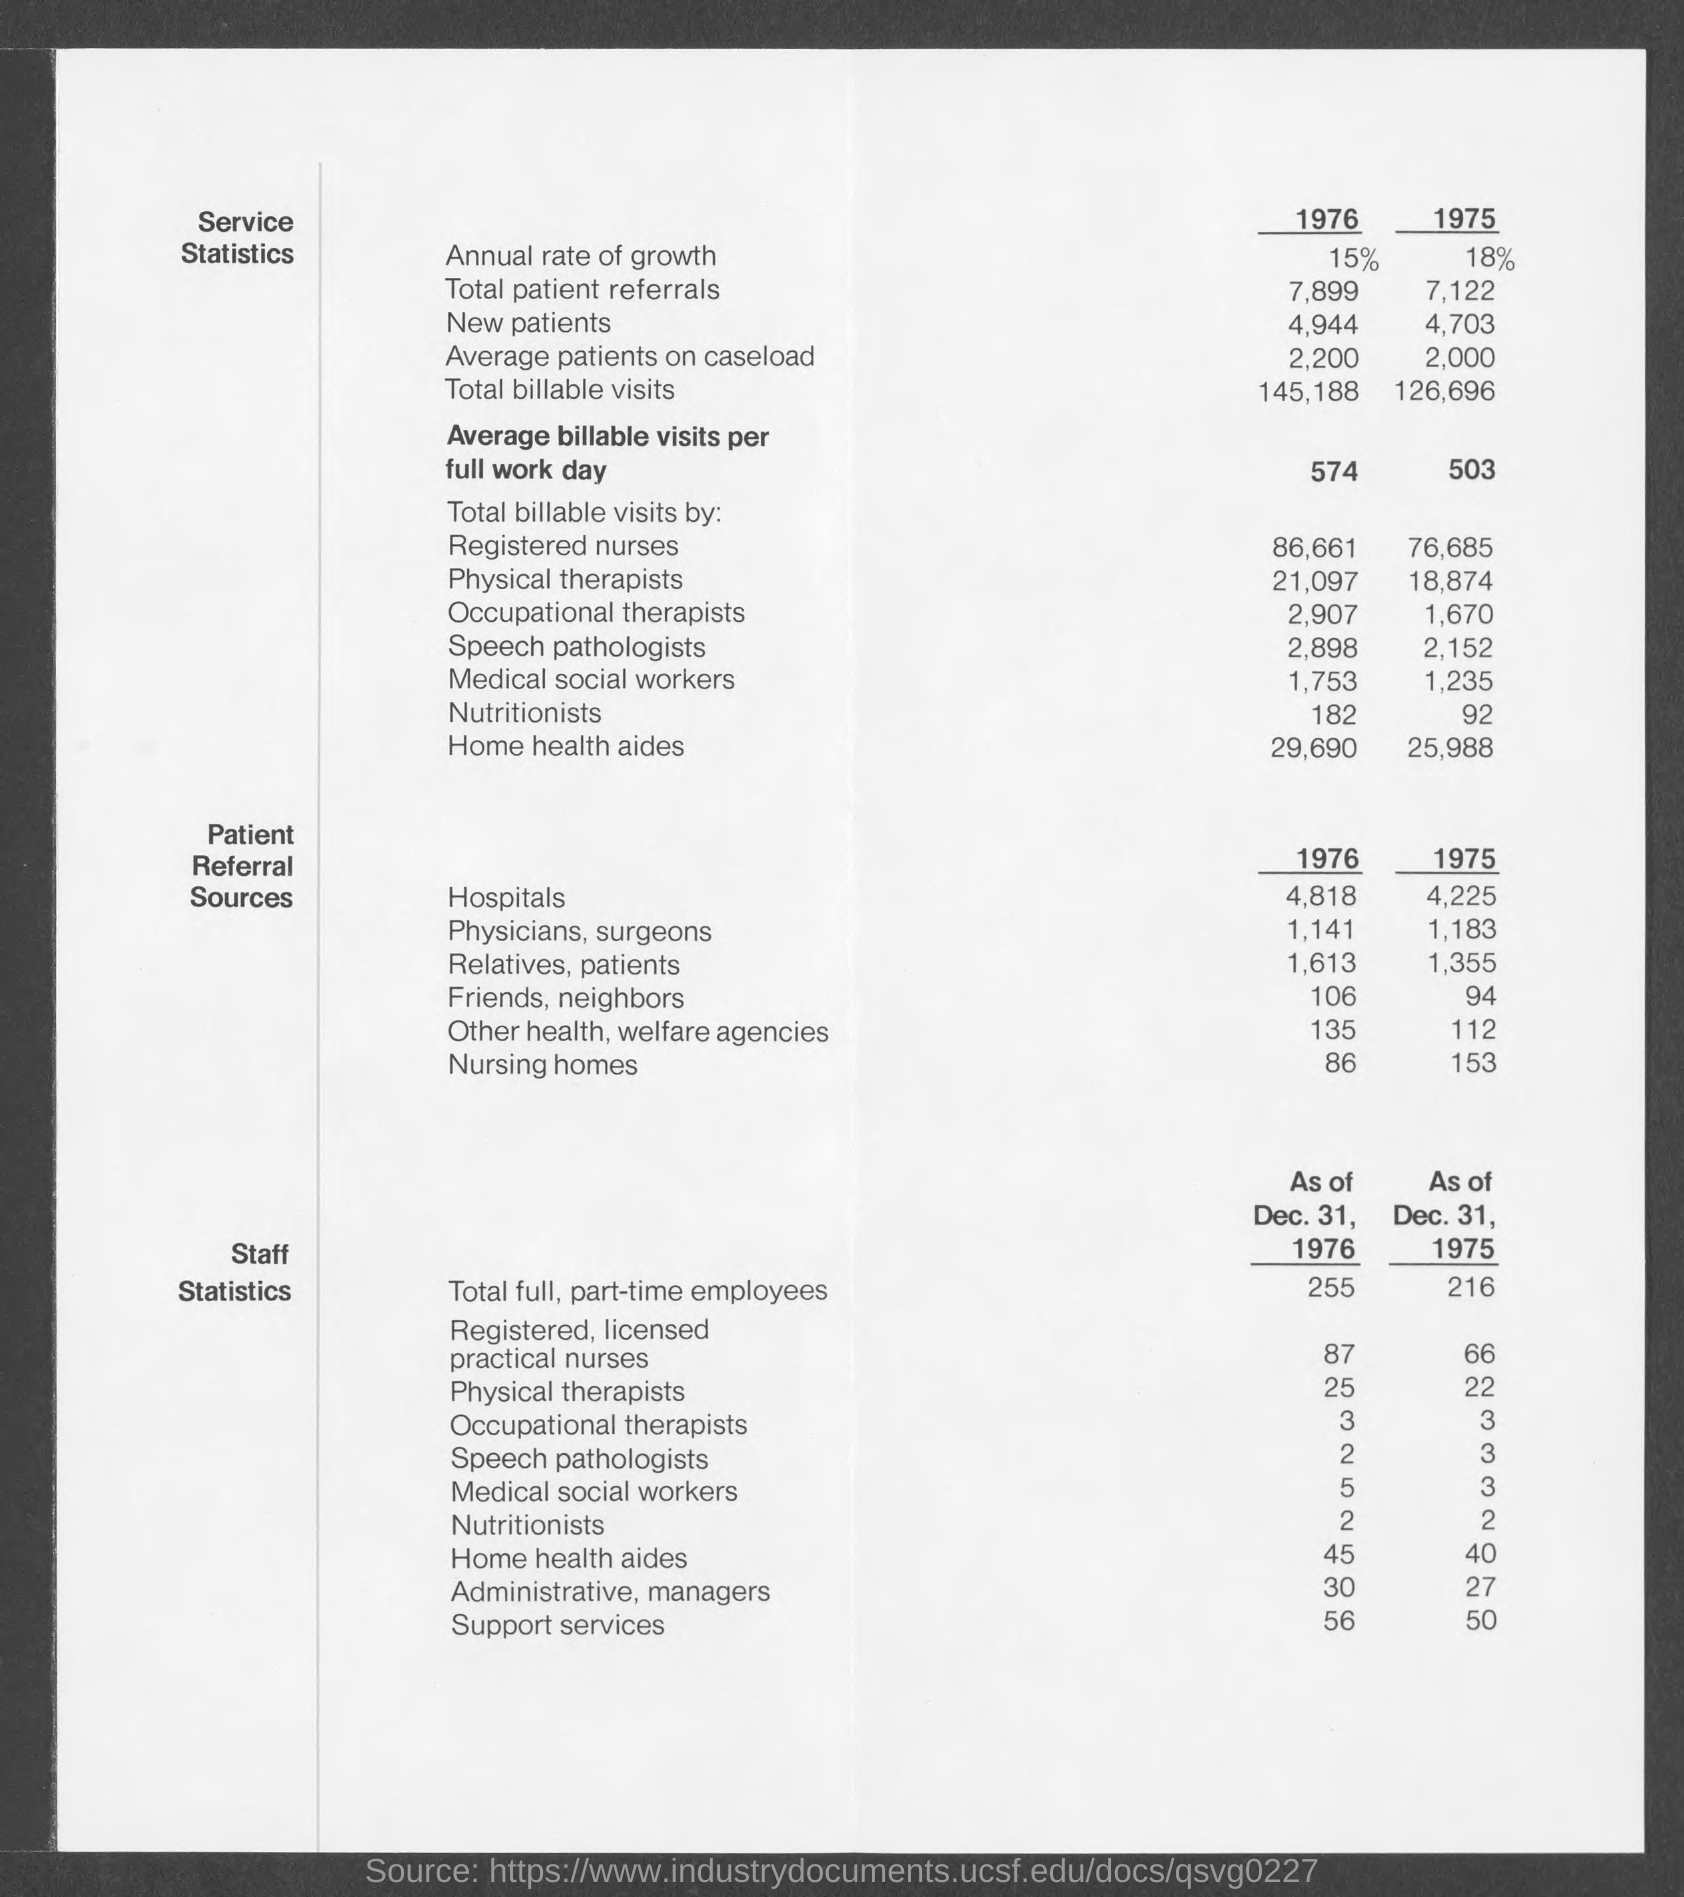Outline some significant characteristics in this image. In 1976, the rate of annual growth was 15%. In 1975, the total number of patient referrals was 7,122. In 1975, the annual rate of growth was 18%. In 1976, the total number of patient referrals was 7,899. 